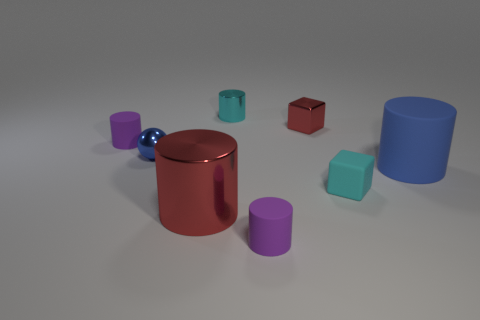Subtract all cyan metallic cylinders. How many cylinders are left? 4 Subtract all purple spheres. How many purple cylinders are left? 2 Subtract all purple cylinders. How many cylinders are left? 3 Add 1 blue balls. How many objects exist? 9 Subtract all brown cylinders. Subtract all green cubes. How many cylinders are left? 5 Subtract all blocks. How many objects are left? 6 Subtract all tiny blue cylinders. Subtract all cylinders. How many objects are left? 3 Add 2 small matte blocks. How many small matte blocks are left? 3 Add 8 gray matte cylinders. How many gray matte cylinders exist? 8 Subtract 1 blue balls. How many objects are left? 7 